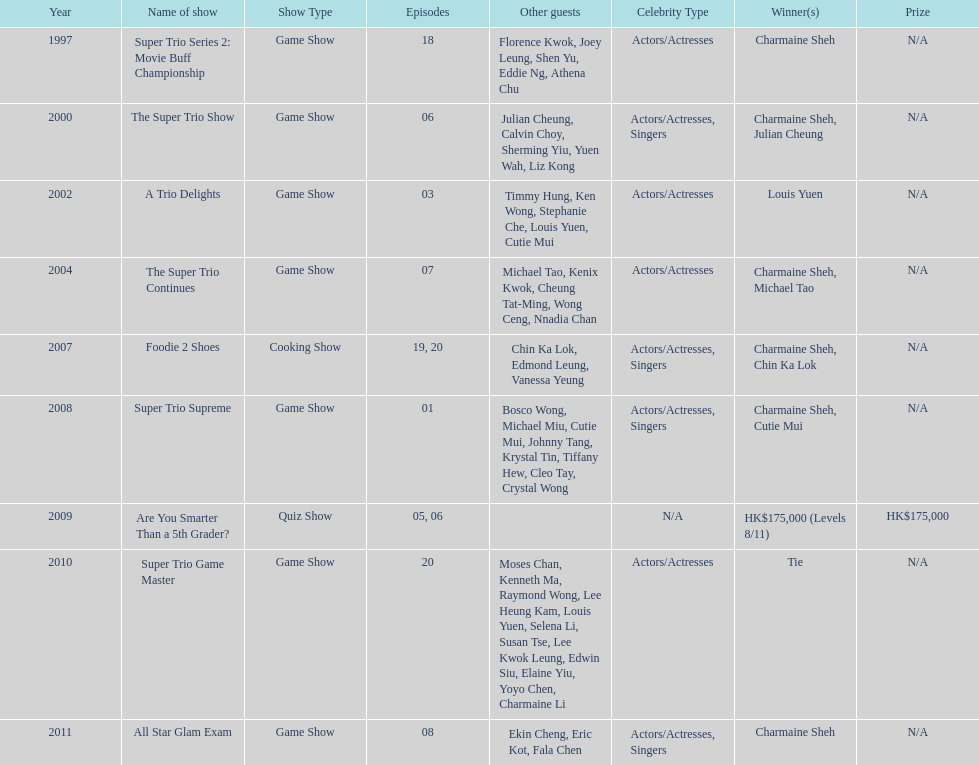In how many television series has charmaine sheh made appearances? 9. 